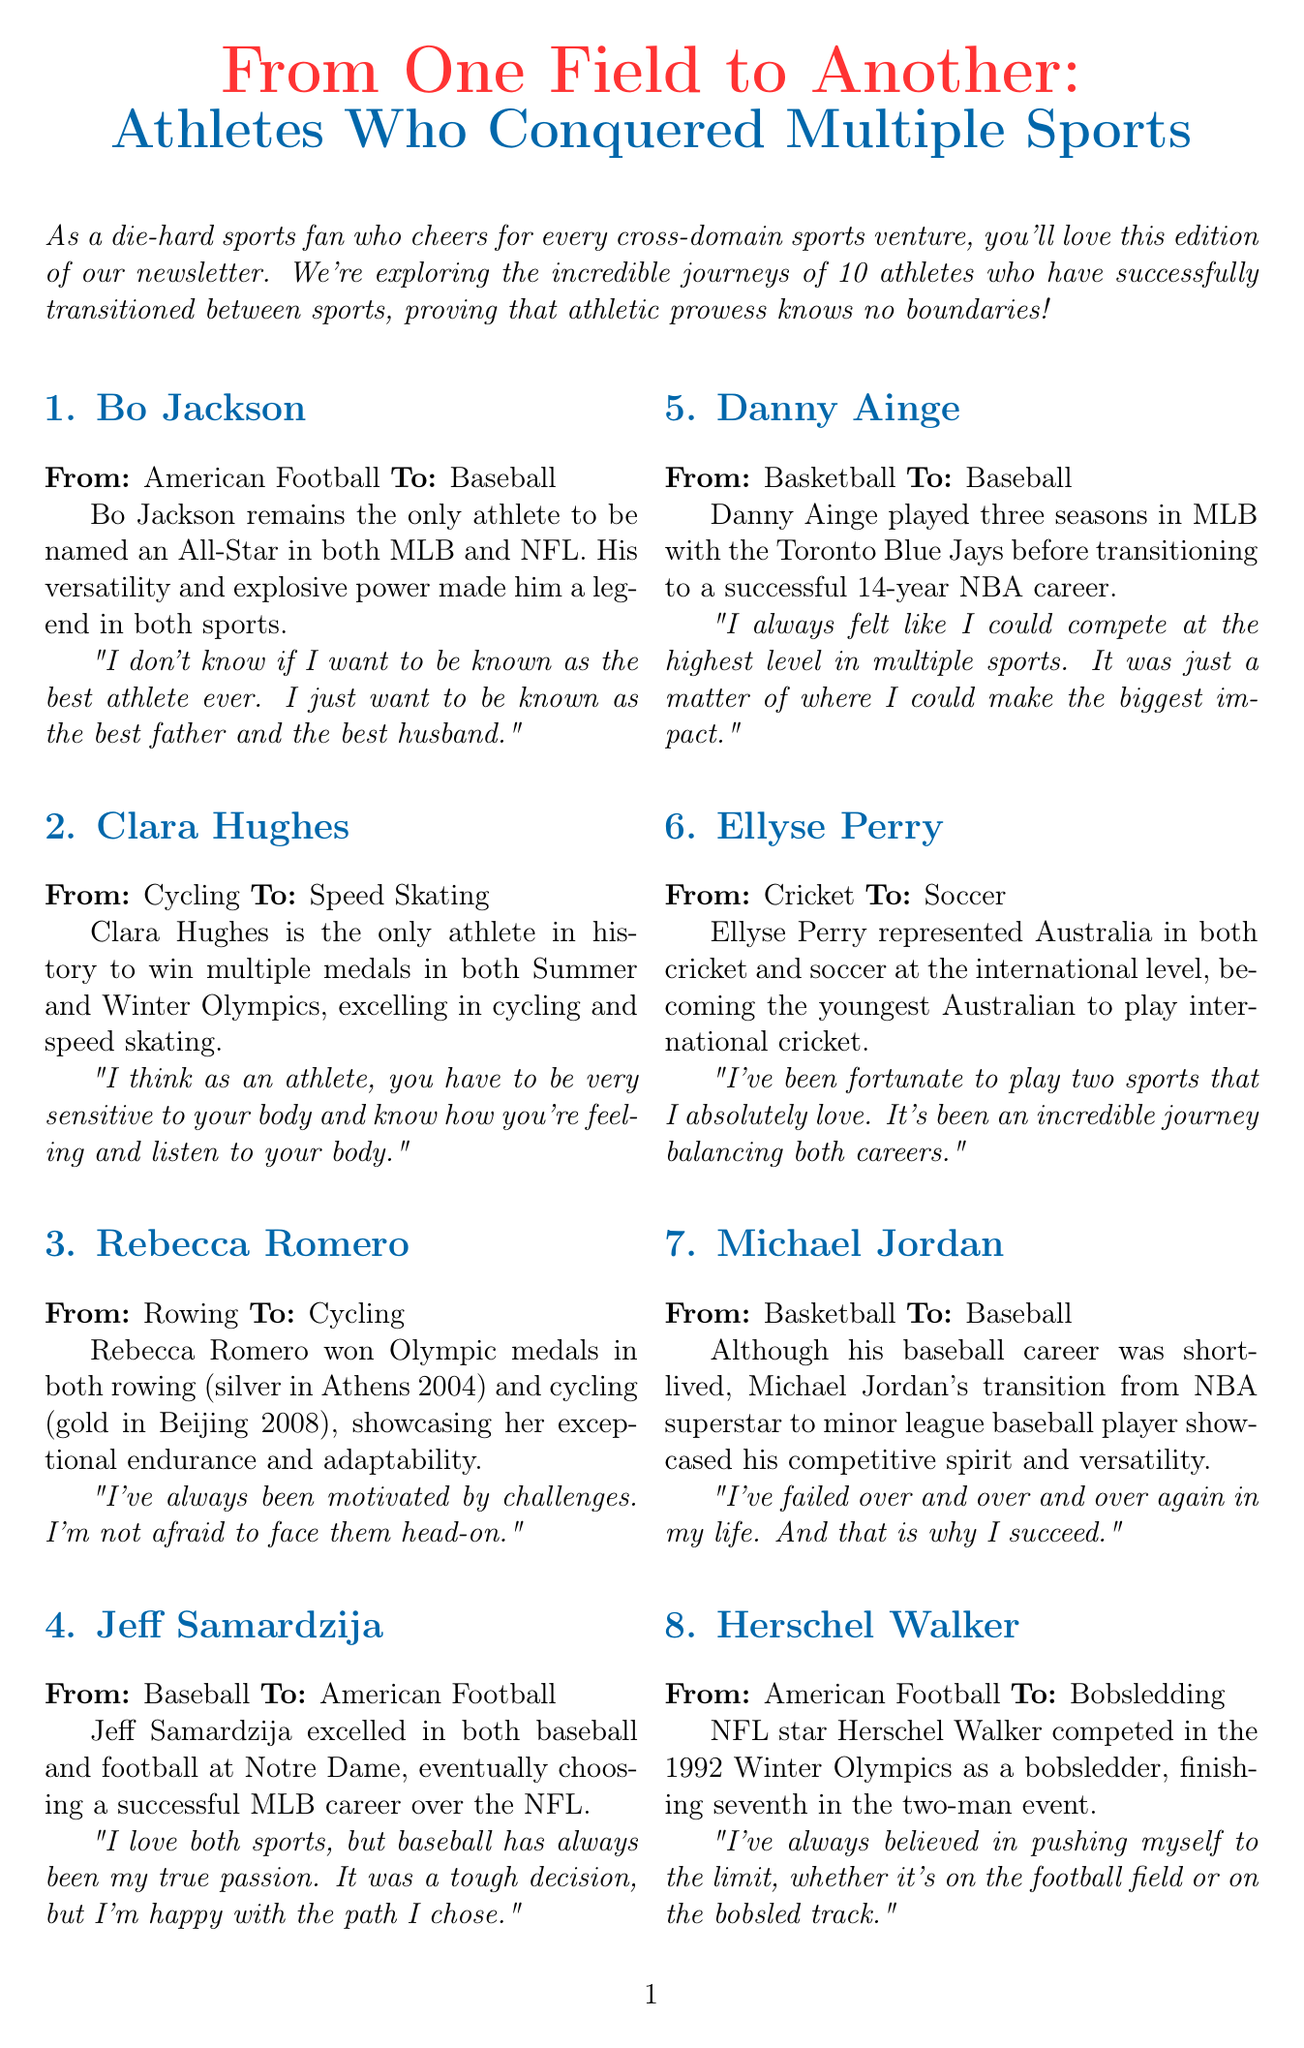what sport did Bo Jackson originally play? Bo Jackson's original sport is mentioned in the introduction of his profile.
Answer: American Football how many Olympic medals did Clara Hughes win? Clara Hughes is noted as the only athlete to win multiple medals, but the exact number is not stated.
Answer: Not specified which athlete transitioned from rowing to cycling? The document explicitly states Rebecca Romero's transition from rowing to cycling.
Answer: Rebecca Romero who was the first woman to win an Olympic boxing gold medal? The newsletter specifically identifies Nicola Adams as the first woman to achieve this.
Answer: Nicola Adams in what year did Michael Jordan attempt to play baseball? The document does not mention a specific year related to during his career in baseball.
Answer: Not specified what was Herschel Walker's new sport? The section describes Herschel Walker's transition after his NFL career.
Answer: Bobsledding which sport did Danny Ainge play before basketball? The document clearly states Danny Ainge's transition before his NBA career.
Answer: Baseball how many sports did Ellyse Perry compete in? The newsletter mentions her representation in two sports at the international level.
Answer: Two what is the title of the newsletter? The title is displayed prominently at the start of the document.
Answer: From One Field to Another: Athletes Who Conquered Multiple Sports 